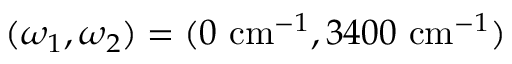<formula> <loc_0><loc_0><loc_500><loc_500>( \omega _ { 1 } , \omega _ { 2 } ) = ( 0 c m ^ { - 1 } , 3 4 0 0 c m ^ { - 1 } )</formula> 